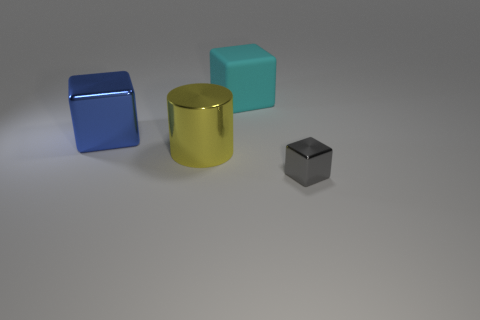Subtract all blocks. How many objects are left? 1 Subtract 1 cylinders. How many cylinders are left? 0 Subtract all brown cylinders. Subtract all cyan cubes. How many cylinders are left? 1 Subtract all gray cylinders. How many gray blocks are left? 1 Subtract all small spheres. Subtract all big cyan rubber blocks. How many objects are left? 3 Add 1 large cyan things. How many large cyan things are left? 2 Add 2 big gray metallic balls. How many big gray metallic balls exist? 2 Add 2 large metal cylinders. How many objects exist? 6 Subtract all metallic cubes. How many cubes are left? 1 Subtract 0 red cubes. How many objects are left? 4 